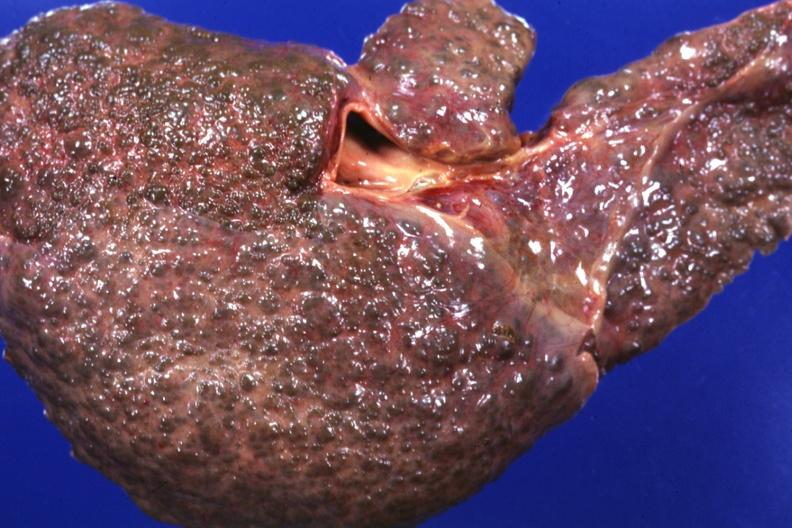what is present?
Answer the question using a single word or phrase. Hepatobiliary 